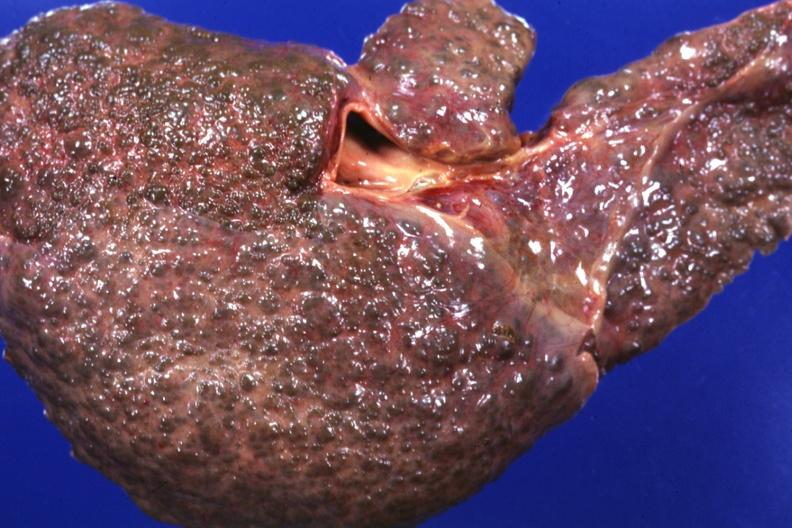what is present?
Answer the question using a single word or phrase. Hepatobiliary 